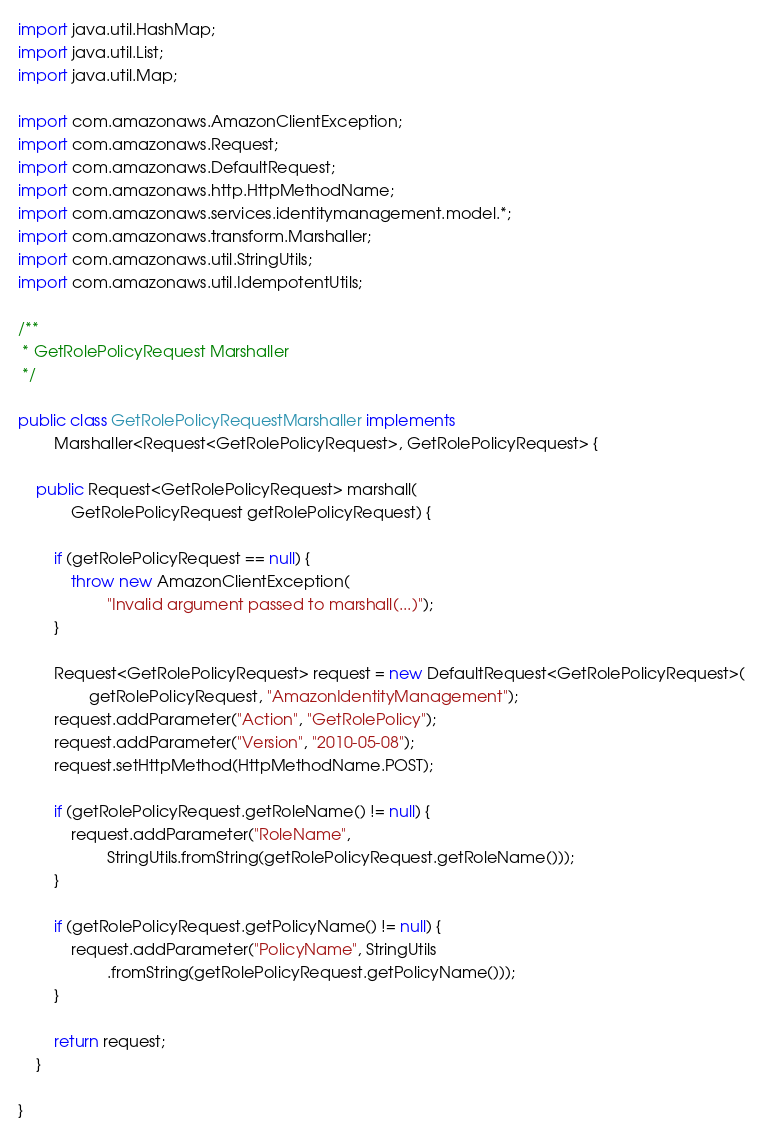<code> <loc_0><loc_0><loc_500><loc_500><_Java_>
import java.util.HashMap;
import java.util.List;
import java.util.Map;

import com.amazonaws.AmazonClientException;
import com.amazonaws.Request;
import com.amazonaws.DefaultRequest;
import com.amazonaws.http.HttpMethodName;
import com.amazonaws.services.identitymanagement.model.*;
import com.amazonaws.transform.Marshaller;
import com.amazonaws.util.StringUtils;
import com.amazonaws.util.IdempotentUtils;

/**
 * GetRolePolicyRequest Marshaller
 */

public class GetRolePolicyRequestMarshaller implements
        Marshaller<Request<GetRolePolicyRequest>, GetRolePolicyRequest> {

    public Request<GetRolePolicyRequest> marshall(
            GetRolePolicyRequest getRolePolicyRequest) {

        if (getRolePolicyRequest == null) {
            throw new AmazonClientException(
                    "Invalid argument passed to marshall(...)");
        }

        Request<GetRolePolicyRequest> request = new DefaultRequest<GetRolePolicyRequest>(
                getRolePolicyRequest, "AmazonIdentityManagement");
        request.addParameter("Action", "GetRolePolicy");
        request.addParameter("Version", "2010-05-08");
        request.setHttpMethod(HttpMethodName.POST);

        if (getRolePolicyRequest.getRoleName() != null) {
            request.addParameter("RoleName",
                    StringUtils.fromString(getRolePolicyRequest.getRoleName()));
        }

        if (getRolePolicyRequest.getPolicyName() != null) {
            request.addParameter("PolicyName", StringUtils
                    .fromString(getRolePolicyRequest.getPolicyName()));
        }

        return request;
    }

}
</code> 